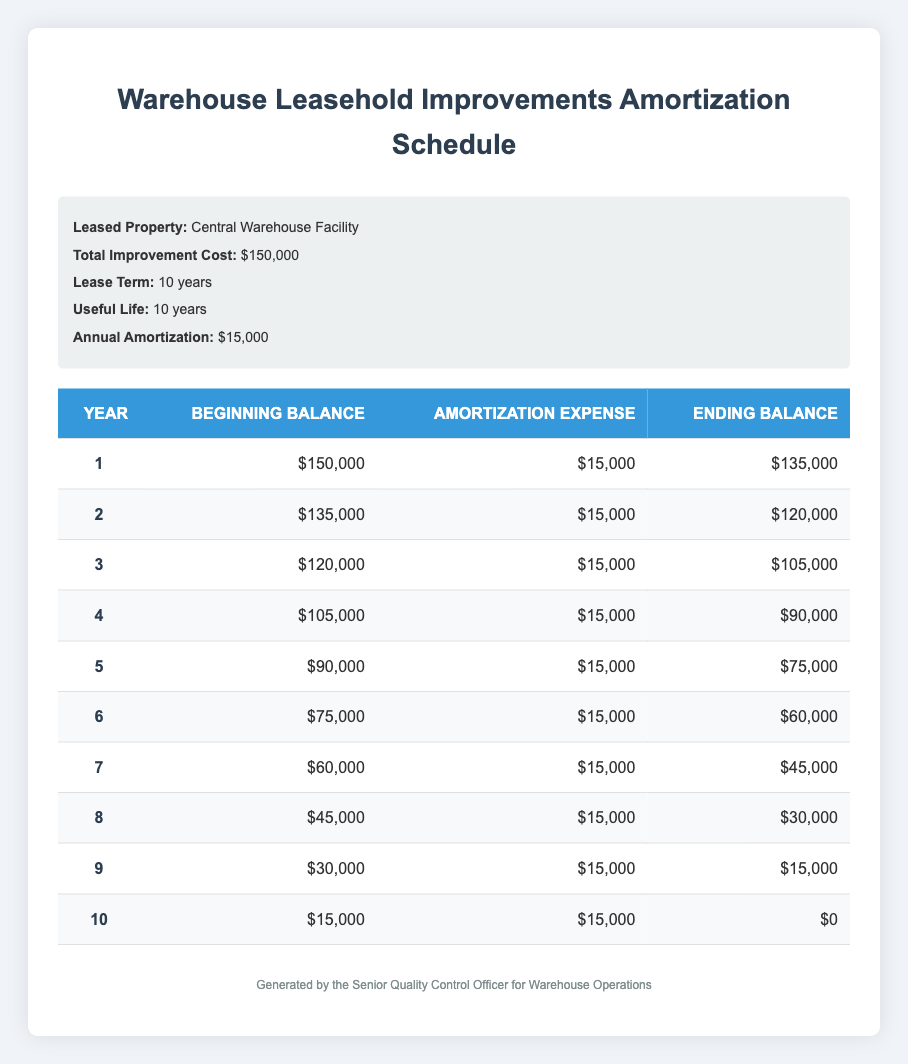What is the total cost of warehouse leasehold improvements? The total cost of warehouse leasehold improvements is stated in the information section of the table. It indicates that the total improvement cost is 150,000.
Answer: 150000 What is the annual amortization amount? The annual amortization amount is directly provided in the information section of the table. It shows that the annual amortization is 15,000.
Answer: 15000 What will be the ending balance after year 3? To find the ending balance after year 3, we look at the third row of the amortization schedule where it shows an ending balance of 105,000.
Answer: 105000 How much will the ending balance reduce from year 4 to year 5? From year 4 to year 5, the ending balance decreases from 90,000 to 75,000. The difference is 90,000 - 75,000 = 15,000.
Answer: 15000 Is the amortization expense the same each year? By examining the amortization expense column in the table, we can see that the amortization expense is consistently 15,000 across all years. Therefore, it is true that the amortization expense is the same each year.
Answer: Yes What is the total amortization expense over the entire lease term? To calculate the total amortization expense over the lease term, we can multiply the annual amortization (15,000) by the lease term (10 years): 15,000 * 10 = 150,000.
Answer: 150000 After how many years will the leasehold improvements be fully amortized? By inspecting the schedule, we see that the ending balance reaches 0 after year 10, indicating that the improvements will be fully amortized after 10 years.
Answer: 10 In which year does the ending balance drop below 60,000 for the first time? Looking through the ending balances, we can see that year 6 ends with 60,000 and year 7 ends with 45,000. Therefore, the ending balance goes below 60,000 for the first time in year 7.
Answer: Year 7 What is the average ending balance over the entire amortization period? To find the average ending balance, we will sum the ending balances for all years (0 + 15,000 + 30,000 + 45,000 + 60,000 + 75,000 + 90,000 + 105,000 + 120,000 + 135,000) which totals 675,000. Then we divide it by the number of years, 10: 675,000 / 10 = 67,500.
Answer: 67500 